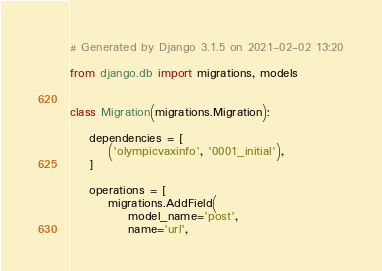<code> <loc_0><loc_0><loc_500><loc_500><_Python_># Generated by Django 3.1.5 on 2021-02-02 13:20

from django.db import migrations, models


class Migration(migrations.Migration):

    dependencies = [
        ('olympicvaxinfo', '0001_initial'),
    ]

    operations = [
        migrations.AddField(
            model_name='post',
            name='url',</code> 